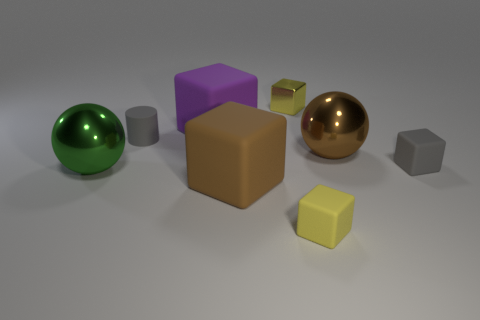There is a gray object that is behind the gray thing on the right side of the large matte cube in front of the cylinder; what size is it?
Keep it short and to the point. Small. There is a matte cylinder; is it the same size as the brown thing on the right side of the small yellow rubber thing?
Your response must be concise. No. What is the color of the small matte thing that is left of the yellow shiny thing?
Offer a very short reply. Gray. There is a tiny rubber object that is the same color as the matte cylinder; what is its shape?
Your answer should be very brief. Cube. What is the shape of the large metallic thing that is left of the cylinder?
Provide a short and direct response. Sphere. What number of green objects are either rubber objects or small matte cubes?
Ensure brevity in your answer.  0. Does the big brown cube have the same material as the gray block?
Offer a terse response. Yes. What number of gray objects are to the right of the large brown sphere?
Make the answer very short. 1. What is the material of the block that is both left of the tiny yellow metal thing and behind the brown metal object?
Your answer should be very brief. Rubber. How many balls are large brown things or metallic objects?
Provide a succinct answer. 2. 